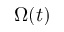<formula> <loc_0><loc_0><loc_500><loc_500>\Omega ( t )</formula> 